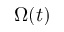<formula> <loc_0><loc_0><loc_500><loc_500>\Omega ( t )</formula> 